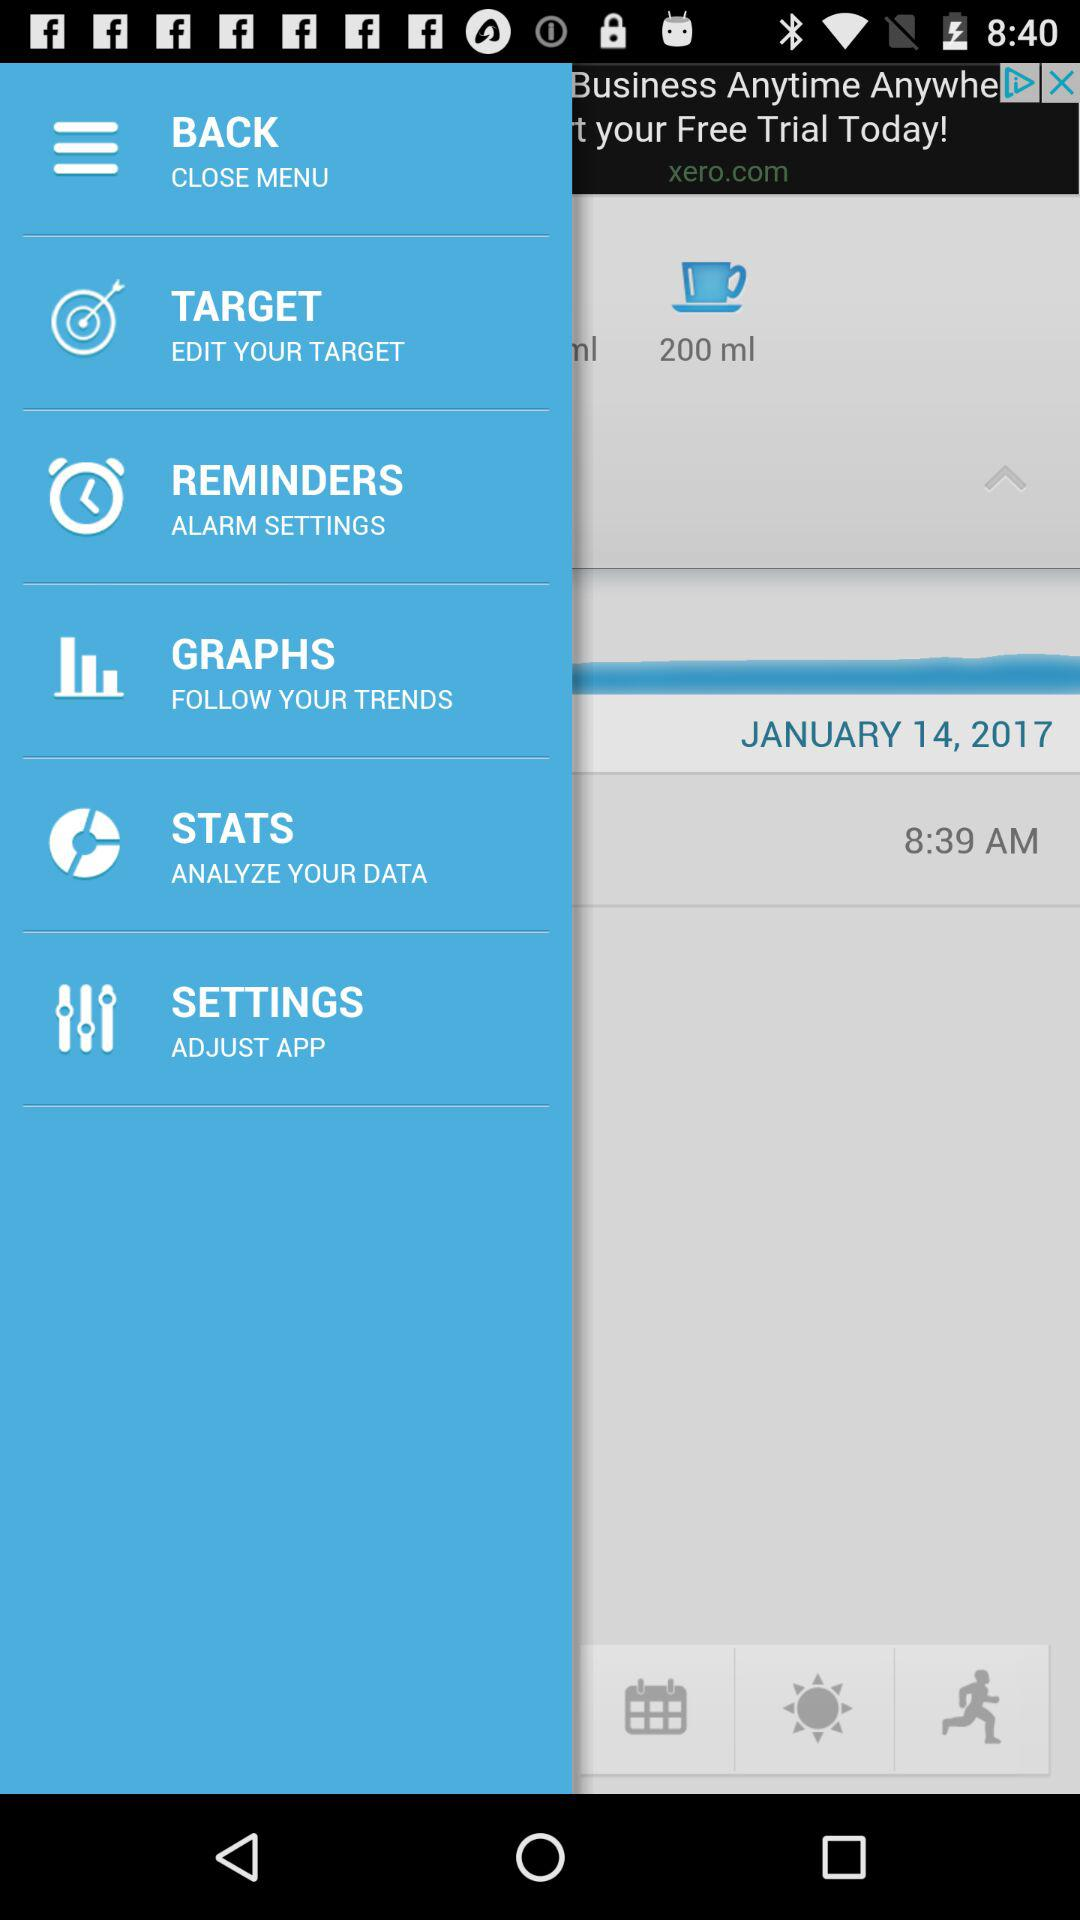What is the size of the cup? The size of the cup is 200 ml. 